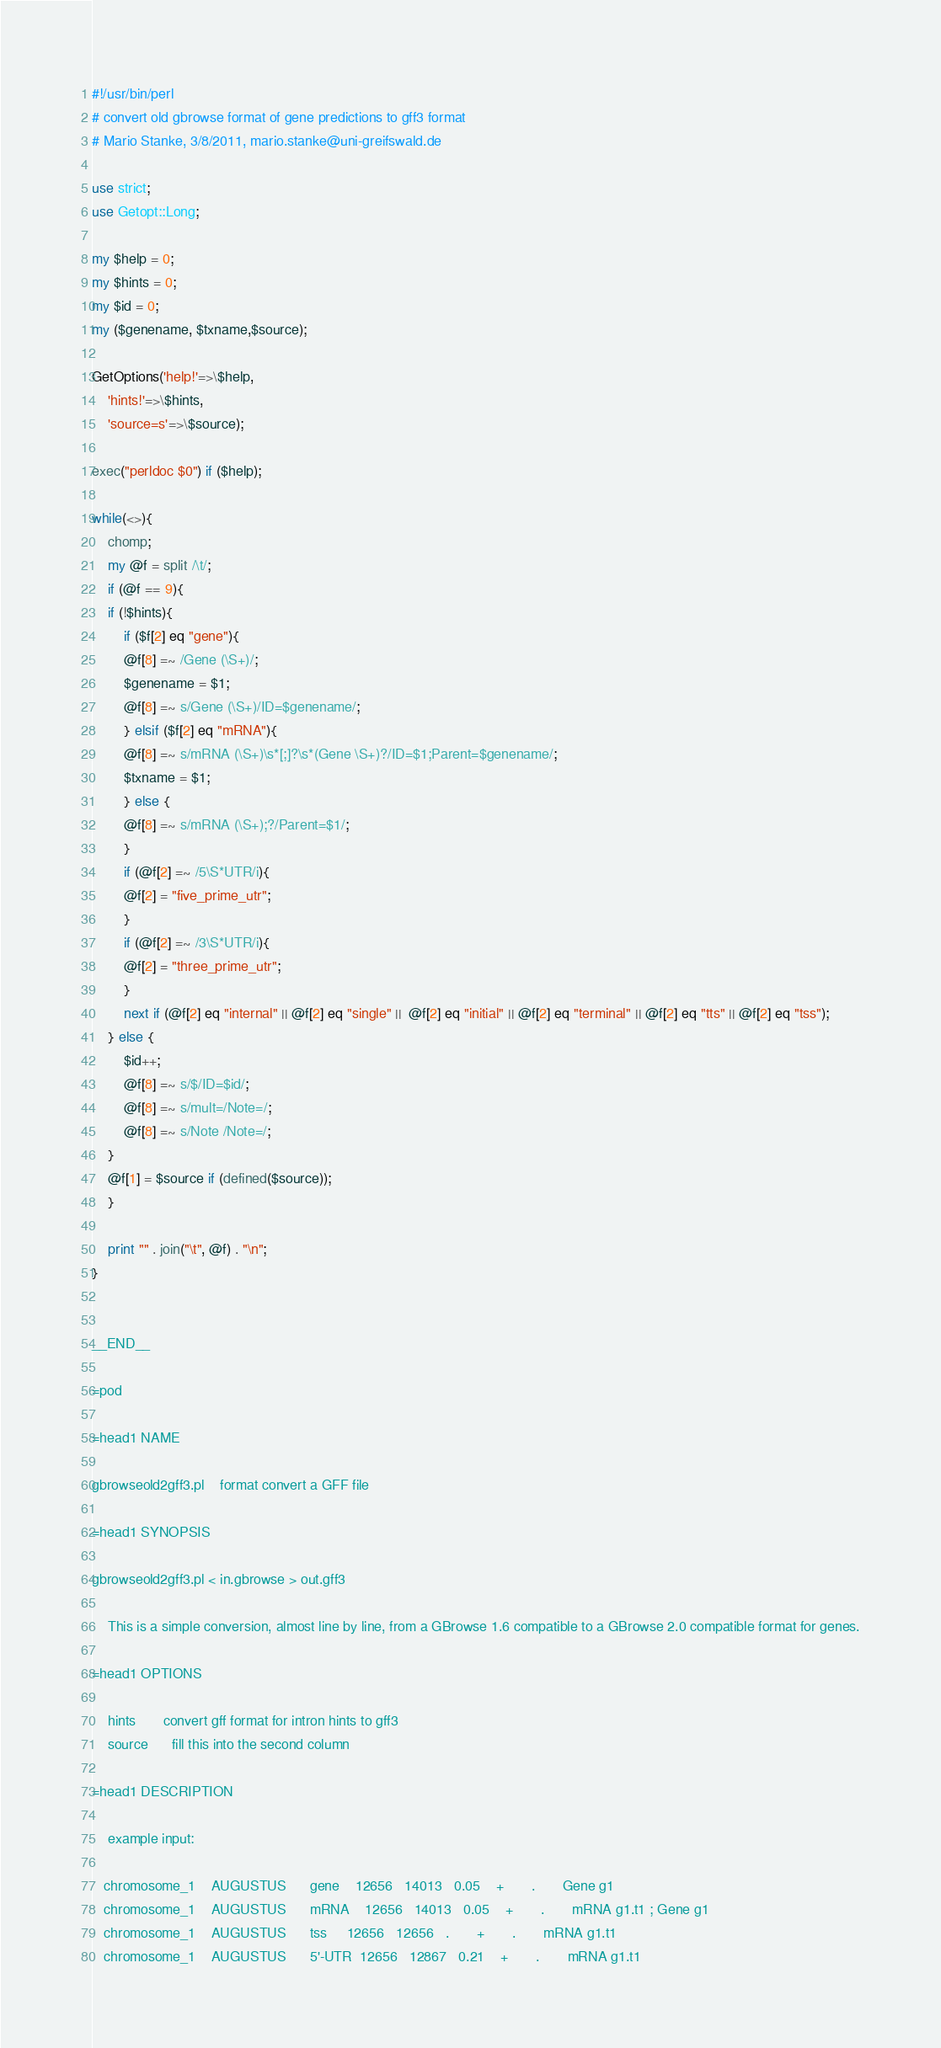Convert code to text. <code><loc_0><loc_0><loc_500><loc_500><_Perl_>#!/usr/bin/perl
# convert old gbrowse format of gene predictions to gff3 format
# Mario Stanke, 3/8/2011, mario.stanke@uni-greifswald.de

use strict;
use Getopt::Long;

my $help = 0;
my $hints = 0;
my $id = 0;
my ($genename, $txname,$source);

GetOptions('help!'=>\$help,
    'hints!'=>\$hints,
    'source=s'=>\$source);

exec("perldoc $0") if ($help);

while(<>){
    chomp;
    my @f = split /\t/;
    if (@f == 9){
	if (!$hints){
	    if ($f[2] eq "gene"){
		@f[8] =~ /Gene (\S+)/;
		$genename = $1;
		@f[8] =~ s/Gene (\S+)/ID=$genename/;
	    } elsif ($f[2] eq "mRNA"){
		@f[8] =~ s/mRNA (\S+)\s*[;]?\s*(Gene \S+)?/ID=$1;Parent=$genename/;
		$txname = $1;
	    } else { 
		@f[8] =~ s/mRNA (\S+);?/Parent=$1/;
	    }
	    if (@f[2] =~ /5\S*UTR/i){
		@f[2] = "five_prime_utr";
	    }
	    if (@f[2] =~ /3\S*UTR/i){
		@f[2] = "three_prime_utr";
	    }
	    next if (@f[2] eq "internal" || @f[2] eq "single" ||  @f[2] eq "initial" || @f[2] eq "terminal" || @f[2] eq "tts" || @f[2] eq "tss");
	} else {
	    $id++;
	    @f[8] =~ s/$/ID=$id/;
	    @f[8] =~ s/mult=/Note=/;
	    @f[8] =~ s/Note /Note=/;
	}
	@f[1] = $source if (defined($source));
    }

    print "" . join("\t", @f) . "\n";
}


__END__

=pod

=head1 NAME

gbrowseold2gff3.pl    format convert a GFF file

=head1 SYNOPSIS

gbrowseold2gff3.pl < in.gbrowse > out.gff3

    This is a simple conversion, almost line by line, from a GBrowse 1.6 compatible to a GBrowse 2.0 compatible format for genes.
    
=head1 OPTIONS

    hints       convert gff format for intron hints to gff3
    source      fill this into the second column

=head1 DESCRIPTION
    
    example input:

   chromosome_1    AUGUSTUS      gene    12656   14013   0.05    +       .       Gene g1
   chromosome_1    AUGUSTUS      mRNA    12656   14013   0.05    +       .       mRNA g1.t1 ; Gene g1
   chromosome_1    AUGUSTUS      tss     12656   12656   .       +       .       mRNA g1.t1
   chromosome_1    AUGUSTUS      5'-UTR  12656   12867   0.21    +       .       mRNA g1.t1</code> 